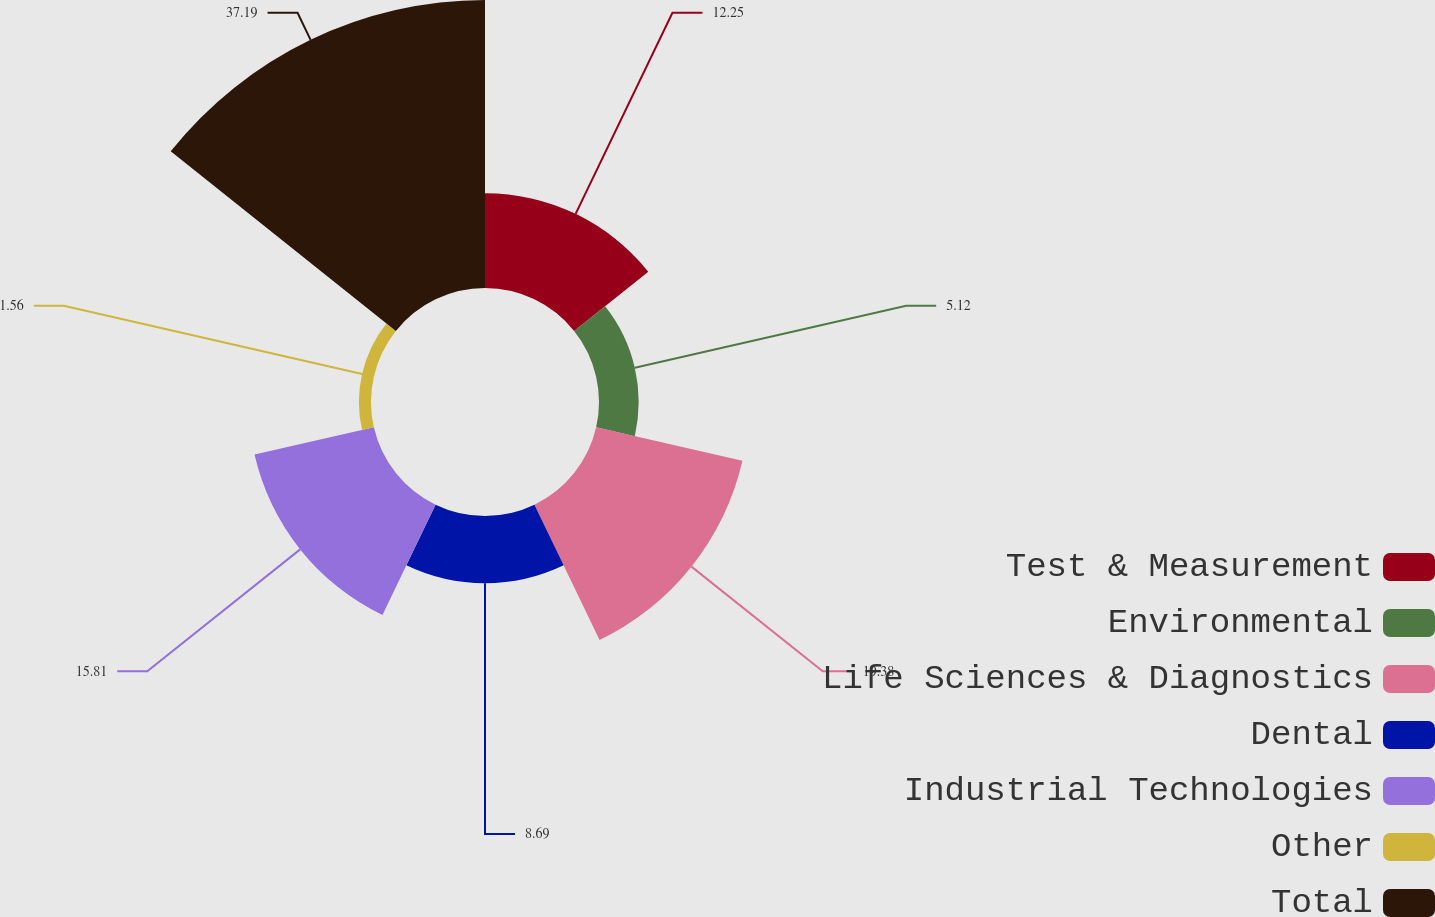Convert chart. <chart><loc_0><loc_0><loc_500><loc_500><pie_chart><fcel>Test & Measurement<fcel>Environmental<fcel>Life Sciences & Diagnostics<fcel>Dental<fcel>Industrial Technologies<fcel>Other<fcel>Total<nl><fcel>12.25%<fcel>5.12%<fcel>19.38%<fcel>8.69%<fcel>15.81%<fcel>1.56%<fcel>37.2%<nl></chart> 